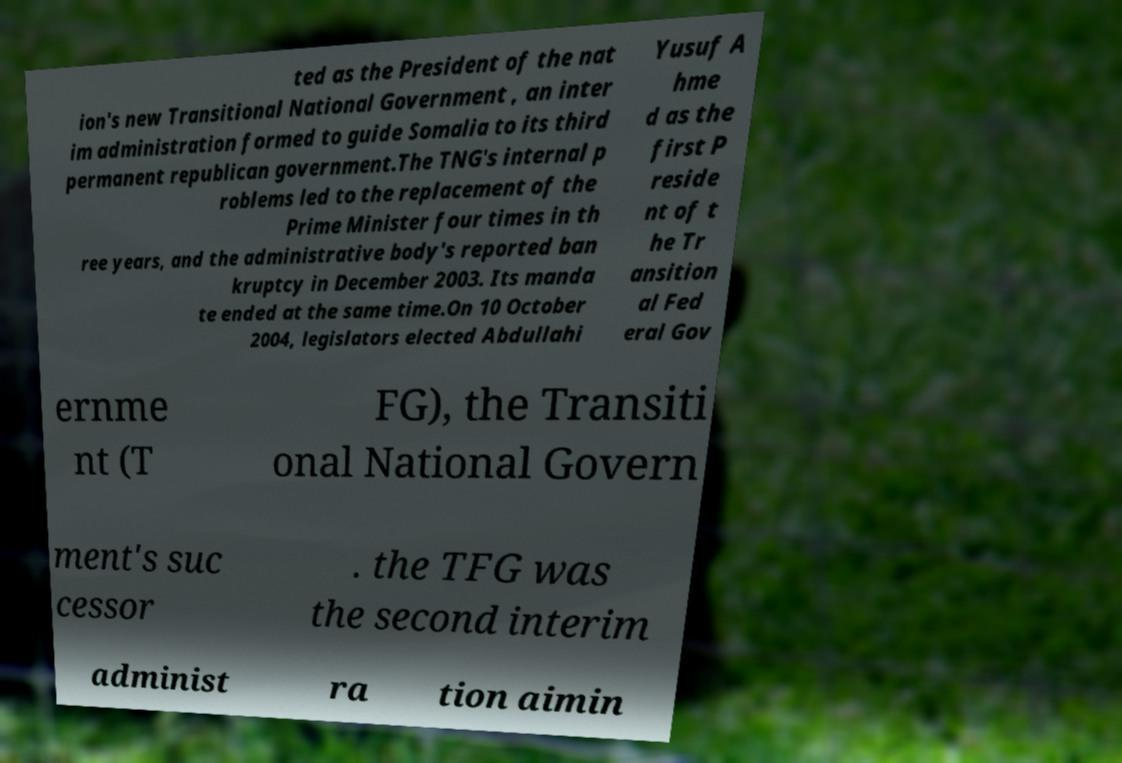Can you read and provide the text displayed in the image?This photo seems to have some interesting text. Can you extract and type it out for me? ted as the President of the nat ion's new Transitional National Government , an inter im administration formed to guide Somalia to its third permanent republican government.The TNG's internal p roblems led to the replacement of the Prime Minister four times in th ree years, and the administrative body's reported ban kruptcy in December 2003. Its manda te ended at the same time.On 10 October 2004, legislators elected Abdullahi Yusuf A hme d as the first P reside nt of t he Tr ansition al Fed eral Gov ernme nt (T FG), the Transiti onal National Govern ment's suc cessor . the TFG was the second interim administ ra tion aimin 